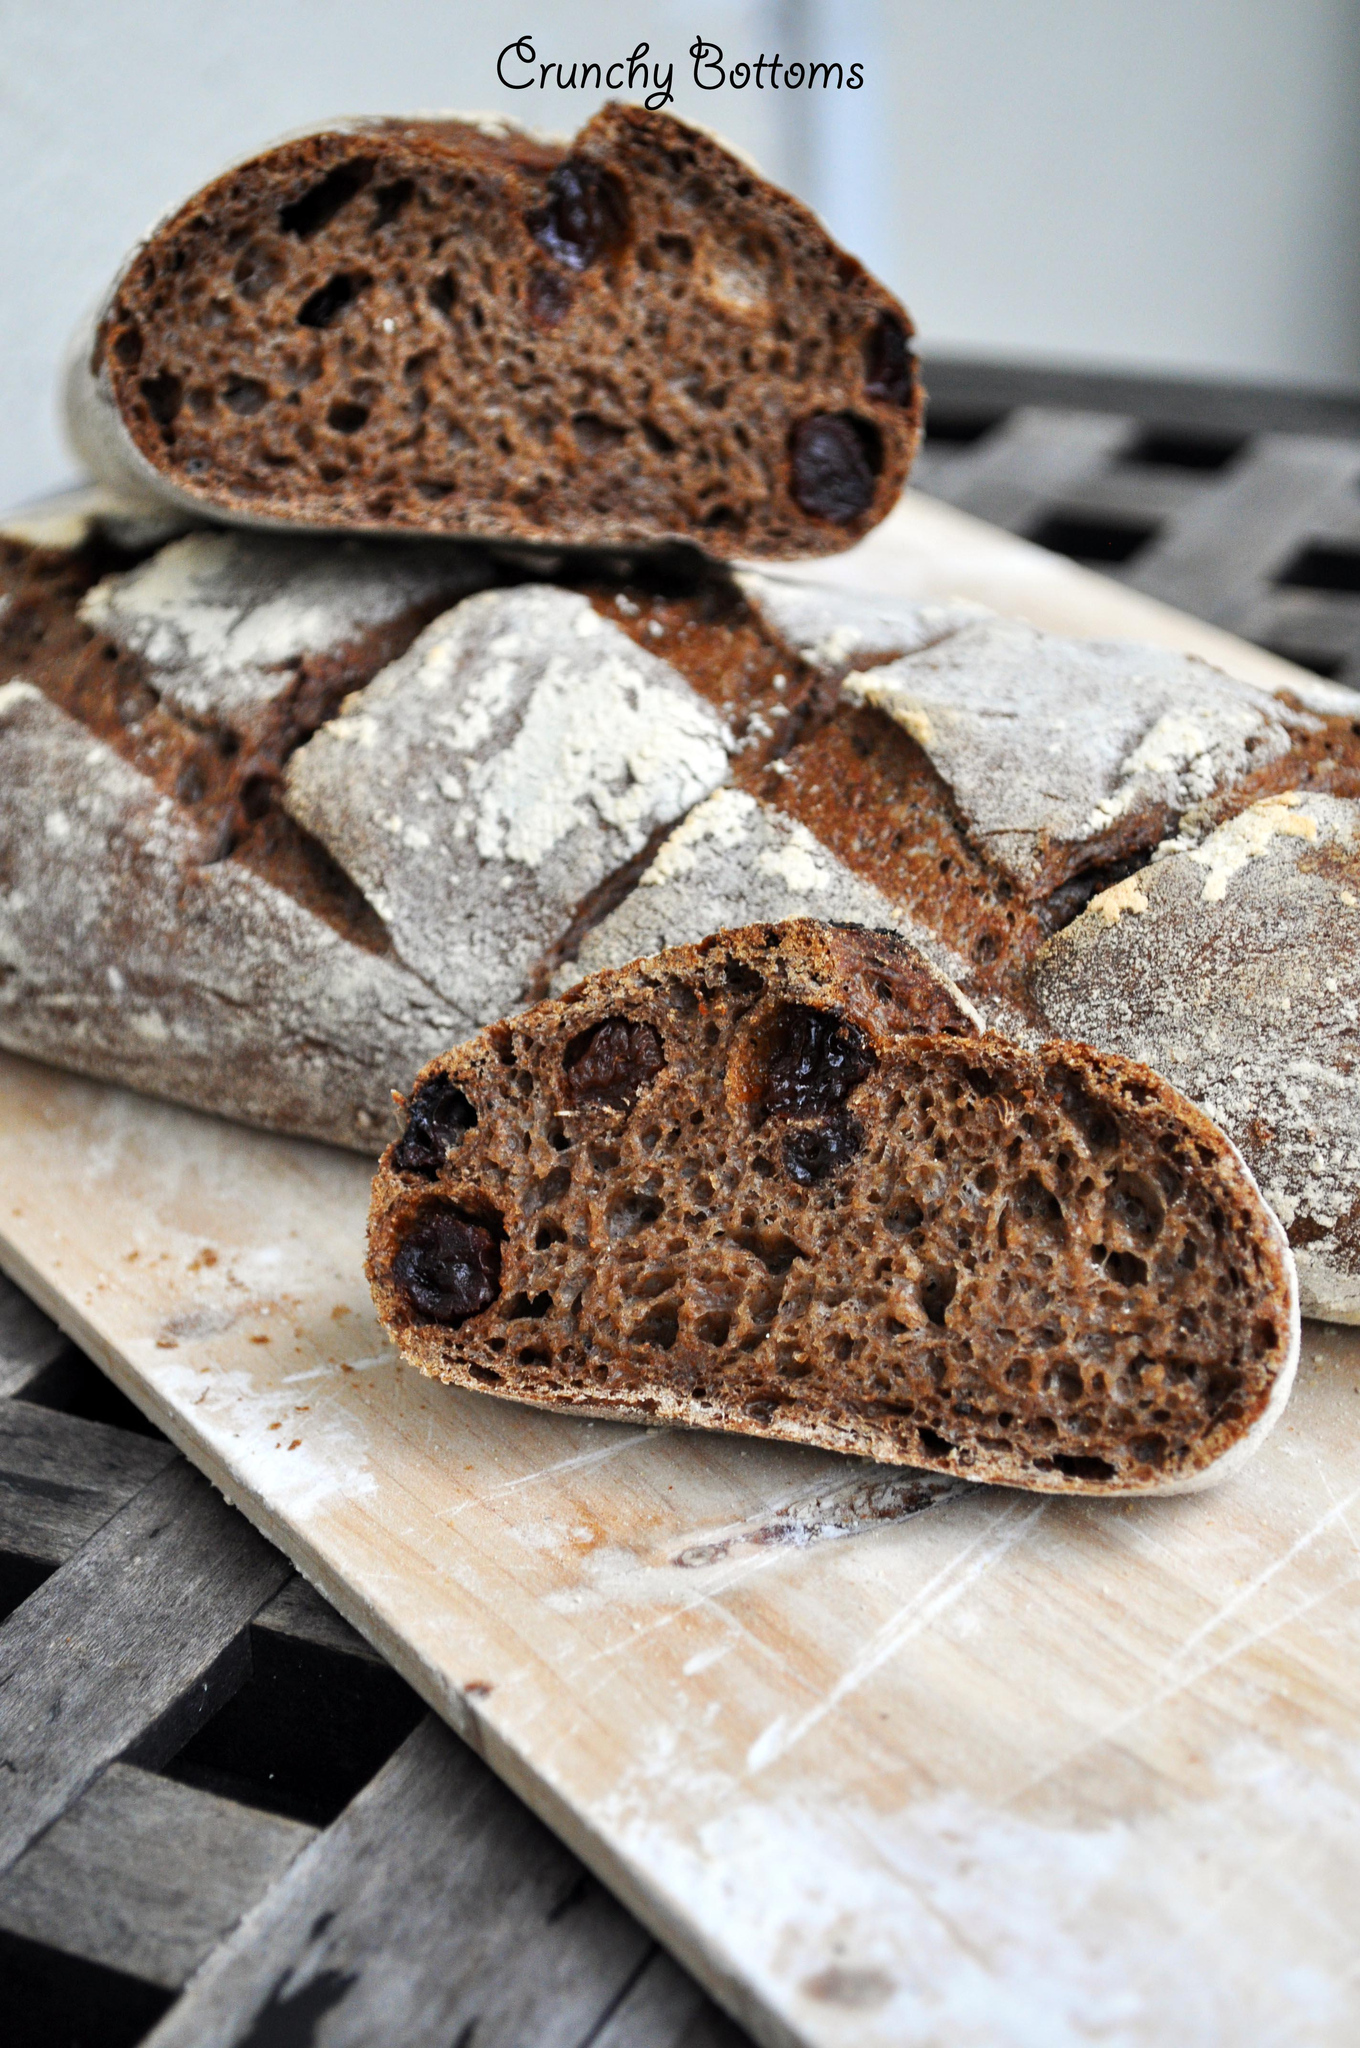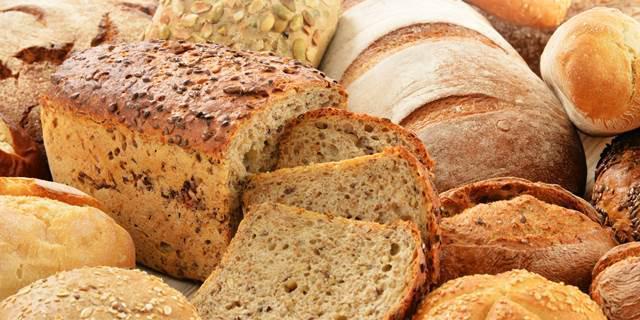The first image is the image on the left, the second image is the image on the right. Examine the images to the left and right. Is the description "None of the bread is cut in at least one of the images." accurate? Answer yes or no. No. The first image is the image on the left, the second image is the image on the right. Considering the images on both sides, is "One of the loaves is placed in an oval dish." valid? Answer yes or no. No. 